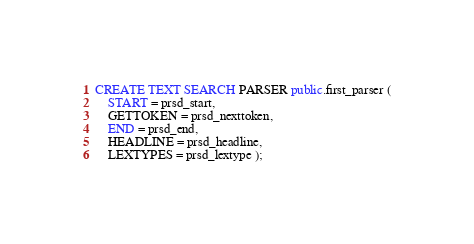<code> <loc_0><loc_0><loc_500><loc_500><_SQL_>CREATE TEXT SEARCH PARSER public.first_parser (
    START = prsd_start,
    GETTOKEN = prsd_nexttoken,
    END = prsd_end,
    HEADLINE = prsd_headline,
    LEXTYPES = prsd_lextype );</code> 